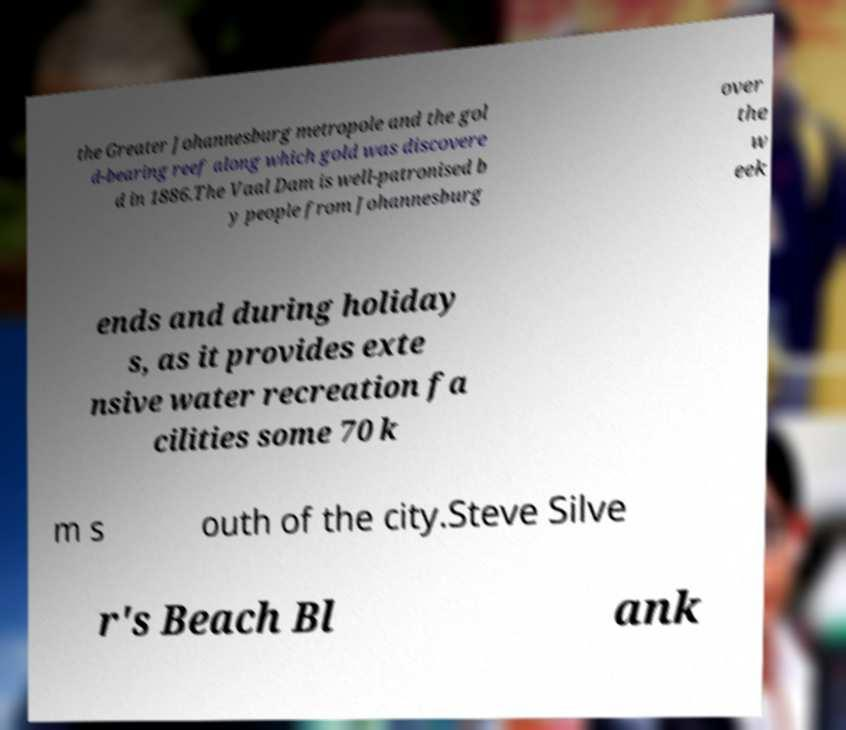I need the written content from this picture converted into text. Can you do that? the Greater Johannesburg metropole and the gol d-bearing reef along which gold was discovere d in 1886.The Vaal Dam is well-patronised b y people from Johannesburg over the w eek ends and during holiday s, as it provides exte nsive water recreation fa cilities some 70 k m s outh of the city.Steve Silve r's Beach Bl ank 